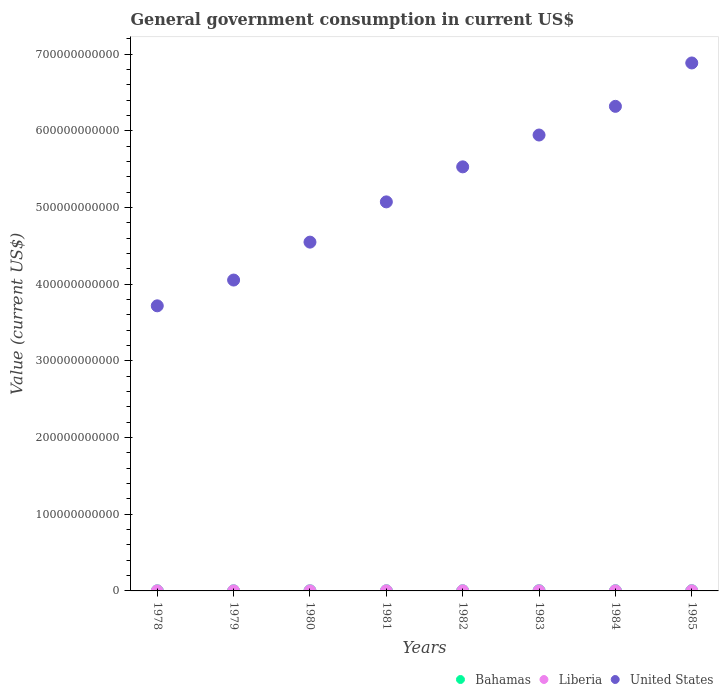What is the government conusmption in United States in 1979?
Provide a short and direct response. 4.05e+11. Across all years, what is the maximum government conusmption in United States?
Offer a terse response. 6.89e+11. Across all years, what is the minimum government conusmption in United States?
Make the answer very short. 3.72e+11. In which year was the government conusmption in Bahamas maximum?
Offer a very short reply. 1985. In which year was the government conusmption in Bahamas minimum?
Your answer should be very brief. 1978. What is the total government conusmption in Bahamas in the graph?
Your answer should be very brief. 1.64e+09. What is the difference between the government conusmption in United States in 1978 and that in 1982?
Make the answer very short. -1.81e+11. What is the difference between the government conusmption in Bahamas in 1985 and the government conusmption in United States in 1978?
Ensure brevity in your answer.  -3.72e+11. What is the average government conusmption in United States per year?
Make the answer very short. 5.26e+11. In the year 1980, what is the difference between the government conusmption in Liberia and government conusmption in United States?
Provide a short and direct response. -4.55e+11. In how many years, is the government conusmption in Bahamas greater than 680000000000 US$?
Offer a very short reply. 0. What is the ratio of the government conusmption in United States in 1979 to that in 1982?
Your answer should be very brief. 0.73. Is the government conusmption in Bahamas in 1978 less than that in 1983?
Keep it short and to the point. Yes. What is the difference between the highest and the second highest government conusmption in United States?
Your answer should be very brief. 5.66e+1. What is the difference between the highest and the lowest government conusmption in Bahamas?
Offer a very short reply. 1.61e+08. In how many years, is the government conusmption in United States greater than the average government conusmption in United States taken over all years?
Your answer should be compact. 4. Is the sum of the government conusmption in Liberia in 1981 and 1982 greater than the maximum government conusmption in United States across all years?
Your answer should be very brief. No. Is it the case that in every year, the sum of the government conusmption in Liberia and government conusmption in Bahamas  is greater than the government conusmption in United States?
Make the answer very short. No. Does the government conusmption in United States monotonically increase over the years?
Provide a short and direct response. Yes. Is the government conusmption in Bahamas strictly greater than the government conusmption in Liberia over the years?
Keep it short and to the point. No. What is the difference between two consecutive major ticks on the Y-axis?
Your answer should be compact. 1.00e+11. Are the values on the major ticks of Y-axis written in scientific E-notation?
Give a very brief answer. No. Does the graph contain grids?
Your answer should be very brief. No. How are the legend labels stacked?
Offer a terse response. Horizontal. What is the title of the graph?
Offer a very short reply. General government consumption in current US$. What is the label or title of the Y-axis?
Provide a succinct answer. Value (current US$). What is the Value (current US$) of Bahamas in 1978?
Your answer should be compact. 1.28e+08. What is the Value (current US$) in Liberia in 1978?
Your answer should be compact. 1.39e+08. What is the Value (current US$) in United States in 1978?
Your response must be concise. 3.72e+11. What is the Value (current US$) in Bahamas in 1979?
Offer a terse response. 1.44e+08. What is the Value (current US$) of Liberia in 1979?
Provide a short and direct response. 1.57e+08. What is the Value (current US$) of United States in 1979?
Ensure brevity in your answer.  4.05e+11. What is the Value (current US$) of Bahamas in 1980?
Your answer should be compact. 1.67e+08. What is the Value (current US$) of Liberia in 1980?
Give a very brief answer. 1.82e+08. What is the Value (current US$) in United States in 1980?
Offer a very short reply. 4.55e+11. What is the Value (current US$) of Bahamas in 1981?
Provide a succinct answer. 1.97e+08. What is the Value (current US$) of Liberia in 1981?
Offer a terse response. 2.11e+08. What is the Value (current US$) of United States in 1981?
Your response must be concise. 5.07e+11. What is the Value (current US$) of Bahamas in 1982?
Provide a succinct answer. 2.09e+08. What is the Value (current US$) of Liberia in 1982?
Your answer should be very brief. 2.43e+08. What is the Value (current US$) in United States in 1982?
Your answer should be very brief. 5.53e+11. What is the Value (current US$) of Bahamas in 1983?
Offer a terse response. 2.38e+08. What is the Value (current US$) in Liberia in 1983?
Ensure brevity in your answer.  2.04e+08. What is the Value (current US$) of United States in 1983?
Keep it short and to the point. 5.95e+11. What is the Value (current US$) of Bahamas in 1984?
Provide a short and direct response. 2.64e+08. What is the Value (current US$) of Liberia in 1984?
Provide a short and direct response. 1.87e+08. What is the Value (current US$) of United States in 1984?
Your answer should be very brief. 6.32e+11. What is the Value (current US$) in Bahamas in 1985?
Keep it short and to the point. 2.89e+08. What is the Value (current US$) in Liberia in 1985?
Keep it short and to the point. 2.30e+08. What is the Value (current US$) in United States in 1985?
Keep it short and to the point. 6.89e+11. Across all years, what is the maximum Value (current US$) in Bahamas?
Offer a very short reply. 2.89e+08. Across all years, what is the maximum Value (current US$) in Liberia?
Give a very brief answer. 2.43e+08. Across all years, what is the maximum Value (current US$) of United States?
Ensure brevity in your answer.  6.89e+11. Across all years, what is the minimum Value (current US$) of Bahamas?
Your answer should be very brief. 1.28e+08. Across all years, what is the minimum Value (current US$) of Liberia?
Your answer should be very brief. 1.39e+08. Across all years, what is the minimum Value (current US$) in United States?
Keep it short and to the point. 3.72e+11. What is the total Value (current US$) in Bahamas in the graph?
Offer a terse response. 1.64e+09. What is the total Value (current US$) of Liberia in the graph?
Your response must be concise. 1.55e+09. What is the total Value (current US$) of United States in the graph?
Give a very brief answer. 4.21e+12. What is the difference between the Value (current US$) in Bahamas in 1978 and that in 1979?
Offer a very short reply. -1.54e+07. What is the difference between the Value (current US$) of Liberia in 1978 and that in 1979?
Make the answer very short. -1.76e+07. What is the difference between the Value (current US$) of United States in 1978 and that in 1979?
Give a very brief answer. -3.36e+1. What is the difference between the Value (current US$) in Bahamas in 1978 and that in 1980?
Ensure brevity in your answer.  -3.86e+07. What is the difference between the Value (current US$) of Liberia in 1978 and that in 1980?
Your answer should be compact. -4.30e+07. What is the difference between the Value (current US$) of United States in 1978 and that in 1980?
Provide a succinct answer. -8.31e+1. What is the difference between the Value (current US$) in Bahamas in 1978 and that in 1981?
Provide a short and direct response. -6.89e+07. What is the difference between the Value (current US$) in Liberia in 1978 and that in 1981?
Your answer should be very brief. -7.20e+07. What is the difference between the Value (current US$) in United States in 1978 and that in 1981?
Your response must be concise. -1.36e+11. What is the difference between the Value (current US$) of Bahamas in 1978 and that in 1982?
Offer a very short reply. -8.05e+07. What is the difference between the Value (current US$) in Liberia in 1978 and that in 1982?
Keep it short and to the point. -1.04e+08. What is the difference between the Value (current US$) in United States in 1978 and that in 1982?
Provide a succinct answer. -1.81e+11. What is the difference between the Value (current US$) of Bahamas in 1978 and that in 1983?
Ensure brevity in your answer.  -1.10e+08. What is the difference between the Value (current US$) of Liberia in 1978 and that in 1983?
Provide a short and direct response. -6.50e+07. What is the difference between the Value (current US$) of United States in 1978 and that in 1983?
Keep it short and to the point. -2.23e+11. What is the difference between the Value (current US$) in Bahamas in 1978 and that in 1984?
Make the answer very short. -1.36e+08. What is the difference between the Value (current US$) in Liberia in 1978 and that in 1984?
Your answer should be very brief. -4.80e+07. What is the difference between the Value (current US$) of United States in 1978 and that in 1984?
Provide a short and direct response. -2.60e+11. What is the difference between the Value (current US$) in Bahamas in 1978 and that in 1985?
Your answer should be very brief. -1.61e+08. What is the difference between the Value (current US$) in Liberia in 1978 and that in 1985?
Offer a very short reply. -9.10e+07. What is the difference between the Value (current US$) in United States in 1978 and that in 1985?
Your answer should be very brief. -3.17e+11. What is the difference between the Value (current US$) of Bahamas in 1979 and that in 1980?
Offer a very short reply. -2.32e+07. What is the difference between the Value (current US$) in Liberia in 1979 and that in 1980?
Provide a succinct answer. -2.54e+07. What is the difference between the Value (current US$) of United States in 1979 and that in 1980?
Ensure brevity in your answer.  -4.95e+1. What is the difference between the Value (current US$) in Bahamas in 1979 and that in 1981?
Keep it short and to the point. -5.35e+07. What is the difference between the Value (current US$) of Liberia in 1979 and that in 1981?
Provide a succinct answer. -5.44e+07. What is the difference between the Value (current US$) in United States in 1979 and that in 1981?
Keep it short and to the point. -1.02e+11. What is the difference between the Value (current US$) of Bahamas in 1979 and that in 1982?
Offer a terse response. -6.51e+07. What is the difference between the Value (current US$) of Liberia in 1979 and that in 1982?
Make the answer very short. -8.64e+07. What is the difference between the Value (current US$) of United States in 1979 and that in 1982?
Your answer should be compact. -1.48e+11. What is the difference between the Value (current US$) of Bahamas in 1979 and that in 1983?
Your response must be concise. -9.42e+07. What is the difference between the Value (current US$) in Liberia in 1979 and that in 1983?
Ensure brevity in your answer.  -4.74e+07. What is the difference between the Value (current US$) of United States in 1979 and that in 1983?
Your answer should be very brief. -1.89e+11. What is the difference between the Value (current US$) in Bahamas in 1979 and that in 1984?
Your response must be concise. -1.20e+08. What is the difference between the Value (current US$) of Liberia in 1979 and that in 1984?
Your answer should be very brief. -3.04e+07. What is the difference between the Value (current US$) in United States in 1979 and that in 1984?
Offer a terse response. -2.27e+11. What is the difference between the Value (current US$) of Bahamas in 1979 and that in 1985?
Offer a terse response. -1.45e+08. What is the difference between the Value (current US$) of Liberia in 1979 and that in 1985?
Your response must be concise. -7.34e+07. What is the difference between the Value (current US$) in United States in 1979 and that in 1985?
Provide a short and direct response. -2.83e+11. What is the difference between the Value (current US$) in Bahamas in 1980 and that in 1981?
Your answer should be compact. -3.03e+07. What is the difference between the Value (current US$) of Liberia in 1980 and that in 1981?
Your answer should be very brief. -2.90e+07. What is the difference between the Value (current US$) of United States in 1980 and that in 1981?
Your answer should be very brief. -5.25e+1. What is the difference between the Value (current US$) of Bahamas in 1980 and that in 1982?
Your answer should be very brief. -4.19e+07. What is the difference between the Value (current US$) of Liberia in 1980 and that in 1982?
Keep it short and to the point. -6.10e+07. What is the difference between the Value (current US$) of United States in 1980 and that in 1982?
Provide a short and direct response. -9.82e+1. What is the difference between the Value (current US$) in Bahamas in 1980 and that in 1983?
Provide a succinct answer. -7.10e+07. What is the difference between the Value (current US$) of Liberia in 1980 and that in 1983?
Offer a very short reply. -2.20e+07. What is the difference between the Value (current US$) of United States in 1980 and that in 1983?
Make the answer very short. -1.40e+11. What is the difference between the Value (current US$) in Bahamas in 1980 and that in 1984?
Your response must be concise. -9.70e+07. What is the difference between the Value (current US$) in Liberia in 1980 and that in 1984?
Your answer should be compact. -5.00e+06. What is the difference between the Value (current US$) of United States in 1980 and that in 1984?
Make the answer very short. -1.77e+11. What is the difference between the Value (current US$) of Bahamas in 1980 and that in 1985?
Keep it short and to the point. -1.22e+08. What is the difference between the Value (current US$) of Liberia in 1980 and that in 1985?
Provide a short and direct response. -4.80e+07. What is the difference between the Value (current US$) of United States in 1980 and that in 1985?
Keep it short and to the point. -2.34e+11. What is the difference between the Value (current US$) of Bahamas in 1981 and that in 1982?
Your answer should be very brief. -1.16e+07. What is the difference between the Value (current US$) of Liberia in 1981 and that in 1982?
Provide a short and direct response. -3.20e+07. What is the difference between the Value (current US$) of United States in 1981 and that in 1982?
Ensure brevity in your answer.  -4.57e+1. What is the difference between the Value (current US$) of Bahamas in 1981 and that in 1983?
Ensure brevity in your answer.  -4.07e+07. What is the difference between the Value (current US$) in Liberia in 1981 and that in 1983?
Your answer should be compact. 7.00e+06. What is the difference between the Value (current US$) of United States in 1981 and that in 1983?
Provide a short and direct response. -8.72e+1. What is the difference between the Value (current US$) in Bahamas in 1981 and that in 1984?
Provide a short and direct response. -6.67e+07. What is the difference between the Value (current US$) in Liberia in 1981 and that in 1984?
Your answer should be compact. 2.40e+07. What is the difference between the Value (current US$) in United States in 1981 and that in 1984?
Give a very brief answer. -1.25e+11. What is the difference between the Value (current US$) of Bahamas in 1981 and that in 1985?
Provide a short and direct response. -9.18e+07. What is the difference between the Value (current US$) of Liberia in 1981 and that in 1985?
Your answer should be compact. -1.90e+07. What is the difference between the Value (current US$) in United States in 1981 and that in 1985?
Ensure brevity in your answer.  -1.81e+11. What is the difference between the Value (current US$) in Bahamas in 1982 and that in 1983?
Keep it short and to the point. -2.91e+07. What is the difference between the Value (current US$) of Liberia in 1982 and that in 1983?
Give a very brief answer. 3.90e+07. What is the difference between the Value (current US$) of United States in 1982 and that in 1983?
Your answer should be very brief. -4.15e+1. What is the difference between the Value (current US$) of Bahamas in 1982 and that in 1984?
Your response must be concise. -5.51e+07. What is the difference between the Value (current US$) in Liberia in 1982 and that in 1984?
Give a very brief answer. 5.60e+07. What is the difference between the Value (current US$) of United States in 1982 and that in 1984?
Provide a succinct answer. -7.89e+1. What is the difference between the Value (current US$) of Bahamas in 1982 and that in 1985?
Your response must be concise. -8.02e+07. What is the difference between the Value (current US$) in Liberia in 1982 and that in 1985?
Your response must be concise. 1.30e+07. What is the difference between the Value (current US$) in United States in 1982 and that in 1985?
Offer a terse response. -1.35e+11. What is the difference between the Value (current US$) in Bahamas in 1983 and that in 1984?
Offer a terse response. -2.60e+07. What is the difference between the Value (current US$) in Liberia in 1983 and that in 1984?
Your answer should be compact. 1.70e+07. What is the difference between the Value (current US$) in United States in 1983 and that in 1984?
Give a very brief answer. -3.74e+1. What is the difference between the Value (current US$) of Bahamas in 1983 and that in 1985?
Your answer should be very brief. -5.11e+07. What is the difference between the Value (current US$) of Liberia in 1983 and that in 1985?
Keep it short and to the point. -2.60e+07. What is the difference between the Value (current US$) in United States in 1983 and that in 1985?
Ensure brevity in your answer.  -9.40e+1. What is the difference between the Value (current US$) of Bahamas in 1984 and that in 1985?
Your response must be concise. -2.51e+07. What is the difference between the Value (current US$) in Liberia in 1984 and that in 1985?
Your answer should be compact. -4.30e+07. What is the difference between the Value (current US$) of United States in 1984 and that in 1985?
Your response must be concise. -5.66e+1. What is the difference between the Value (current US$) in Bahamas in 1978 and the Value (current US$) in Liberia in 1979?
Provide a succinct answer. -2.82e+07. What is the difference between the Value (current US$) in Bahamas in 1978 and the Value (current US$) in United States in 1979?
Your response must be concise. -4.05e+11. What is the difference between the Value (current US$) in Liberia in 1978 and the Value (current US$) in United States in 1979?
Provide a succinct answer. -4.05e+11. What is the difference between the Value (current US$) of Bahamas in 1978 and the Value (current US$) of Liberia in 1980?
Provide a short and direct response. -5.36e+07. What is the difference between the Value (current US$) in Bahamas in 1978 and the Value (current US$) in United States in 1980?
Your answer should be very brief. -4.55e+11. What is the difference between the Value (current US$) in Liberia in 1978 and the Value (current US$) in United States in 1980?
Your answer should be very brief. -4.55e+11. What is the difference between the Value (current US$) of Bahamas in 1978 and the Value (current US$) of Liberia in 1981?
Provide a short and direct response. -8.26e+07. What is the difference between the Value (current US$) of Bahamas in 1978 and the Value (current US$) of United States in 1981?
Provide a succinct answer. -5.07e+11. What is the difference between the Value (current US$) in Liberia in 1978 and the Value (current US$) in United States in 1981?
Your response must be concise. -5.07e+11. What is the difference between the Value (current US$) in Bahamas in 1978 and the Value (current US$) in Liberia in 1982?
Your answer should be very brief. -1.15e+08. What is the difference between the Value (current US$) in Bahamas in 1978 and the Value (current US$) in United States in 1982?
Make the answer very short. -5.53e+11. What is the difference between the Value (current US$) of Liberia in 1978 and the Value (current US$) of United States in 1982?
Offer a terse response. -5.53e+11. What is the difference between the Value (current US$) in Bahamas in 1978 and the Value (current US$) in Liberia in 1983?
Your answer should be compact. -7.56e+07. What is the difference between the Value (current US$) of Bahamas in 1978 and the Value (current US$) of United States in 1983?
Your answer should be very brief. -5.94e+11. What is the difference between the Value (current US$) of Liberia in 1978 and the Value (current US$) of United States in 1983?
Your answer should be very brief. -5.94e+11. What is the difference between the Value (current US$) in Bahamas in 1978 and the Value (current US$) in Liberia in 1984?
Keep it short and to the point. -5.86e+07. What is the difference between the Value (current US$) in Bahamas in 1978 and the Value (current US$) in United States in 1984?
Offer a very short reply. -6.32e+11. What is the difference between the Value (current US$) in Liberia in 1978 and the Value (current US$) in United States in 1984?
Provide a succinct answer. -6.32e+11. What is the difference between the Value (current US$) in Bahamas in 1978 and the Value (current US$) in Liberia in 1985?
Give a very brief answer. -1.02e+08. What is the difference between the Value (current US$) of Bahamas in 1978 and the Value (current US$) of United States in 1985?
Keep it short and to the point. -6.88e+11. What is the difference between the Value (current US$) in Liberia in 1978 and the Value (current US$) in United States in 1985?
Offer a very short reply. -6.88e+11. What is the difference between the Value (current US$) of Bahamas in 1979 and the Value (current US$) of Liberia in 1980?
Offer a very short reply. -3.82e+07. What is the difference between the Value (current US$) in Bahamas in 1979 and the Value (current US$) in United States in 1980?
Your response must be concise. -4.55e+11. What is the difference between the Value (current US$) of Liberia in 1979 and the Value (current US$) of United States in 1980?
Your answer should be very brief. -4.55e+11. What is the difference between the Value (current US$) of Bahamas in 1979 and the Value (current US$) of Liberia in 1981?
Ensure brevity in your answer.  -6.72e+07. What is the difference between the Value (current US$) of Bahamas in 1979 and the Value (current US$) of United States in 1981?
Offer a terse response. -5.07e+11. What is the difference between the Value (current US$) in Liberia in 1979 and the Value (current US$) in United States in 1981?
Ensure brevity in your answer.  -5.07e+11. What is the difference between the Value (current US$) in Bahamas in 1979 and the Value (current US$) in Liberia in 1982?
Make the answer very short. -9.92e+07. What is the difference between the Value (current US$) in Bahamas in 1979 and the Value (current US$) in United States in 1982?
Ensure brevity in your answer.  -5.53e+11. What is the difference between the Value (current US$) in Liberia in 1979 and the Value (current US$) in United States in 1982?
Provide a succinct answer. -5.53e+11. What is the difference between the Value (current US$) in Bahamas in 1979 and the Value (current US$) in Liberia in 1983?
Make the answer very short. -6.02e+07. What is the difference between the Value (current US$) in Bahamas in 1979 and the Value (current US$) in United States in 1983?
Keep it short and to the point. -5.94e+11. What is the difference between the Value (current US$) of Liberia in 1979 and the Value (current US$) of United States in 1983?
Offer a very short reply. -5.94e+11. What is the difference between the Value (current US$) of Bahamas in 1979 and the Value (current US$) of Liberia in 1984?
Provide a succinct answer. -4.32e+07. What is the difference between the Value (current US$) in Bahamas in 1979 and the Value (current US$) in United States in 1984?
Make the answer very short. -6.32e+11. What is the difference between the Value (current US$) of Liberia in 1979 and the Value (current US$) of United States in 1984?
Give a very brief answer. -6.32e+11. What is the difference between the Value (current US$) of Bahamas in 1979 and the Value (current US$) of Liberia in 1985?
Keep it short and to the point. -8.62e+07. What is the difference between the Value (current US$) in Bahamas in 1979 and the Value (current US$) in United States in 1985?
Your response must be concise. -6.88e+11. What is the difference between the Value (current US$) in Liberia in 1979 and the Value (current US$) in United States in 1985?
Your response must be concise. -6.88e+11. What is the difference between the Value (current US$) of Bahamas in 1980 and the Value (current US$) of Liberia in 1981?
Your answer should be very brief. -4.40e+07. What is the difference between the Value (current US$) in Bahamas in 1980 and the Value (current US$) in United States in 1981?
Your answer should be compact. -5.07e+11. What is the difference between the Value (current US$) in Liberia in 1980 and the Value (current US$) in United States in 1981?
Offer a very short reply. -5.07e+11. What is the difference between the Value (current US$) of Bahamas in 1980 and the Value (current US$) of Liberia in 1982?
Provide a short and direct response. -7.60e+07. What is the difference between the Value (current US$) in Bahamas in 1980 and the Value (current US$) in United States in 1982?
Keep it short and to the point. -5.53e+11. What is the difference between the Value (current US$) of Liberia in 1980 and the Value (current US$) of United States in 1982?
Provide a short and direct response. -5.53e+11. What is the difference between the Value (current US$) in Bahamas in 1980 and the Value (current US$) in Liberia in 1983?
Provide a succinct answer. -3.70e+07. What is the difference between the Value (current US$) of Bahamas in 1980 and the Value (current US$) of United States in 1983?
Provide a succinct answer. -5.94e+11. What is the difference between the Value (current US$) of Liberia in 1980 and the Value (current US$) of United States in 1983?
Provide a short and direct response. -5.94e+11. What is the difference between the Value (current US$) in Bahamas in 1980 and the Value (current US$) in Liberia in 1984?
Offer a terse response. -2.00e+07. What is the difference between the Value (current US$) in Bahamas in 1980 and the Value (current US$) in United States in 1984?
Offer a terse response. -6.32e+11. What is the difference between the Value (current US$) in Liberia in 1980 and the Value (current US$) in United States in 1984?
Your response must be concise. -6.32e+11. What is the difference between the Value (current US$) in Bahamas in 1980 and the Value (current US$) in Liberia in 1985?
Ensure brevity in your answer.  -6.30e+07. What is the difference between the Value (current US$) in Bahamas in 1980 and the Value (current US$) in United States in 1985?
Your response must be concise. -6.88e+11. What is the difference between the Value (current US$) of Liberia in 1980 and the Value (current US$) of United States in 1985?
Make the answer very short. -6.88e+11. What is the difference between the Value (current US$) of Bahamas in 1981 and the Value (current US$) of Liberia in 1982?
Your answer should be very brief. -4.57e+07. What is the difference between the Value (current US$) in Bahamas in 1981 and the Value (current US$) in United States in 1982?
Provide a short and direct response. -5.53e+11. What is the difference between the Value (current US$) in Liberia in 1981 and the Value (current US$) in United States in 1982?
Give a very brief answer. -5.53e+11. What is the difference between the Value (current US$) of Bahamas in 1981 and the Value (current US$) of Liberia in 1983?
Keep it short and to the point. -6.70e+06. What is the difference between the Value (current US$) in Bahamas in 1981 and the Value (current US$) in United States in 1983?
Offer a terse response. -5.94e+11. What is the difference between the Value (current US$) of Liberia in 1981 and the Value (current US$) of United States in 1983?
Provide a short and direct response. -5.94e+11. What is the difference between the Value (current US$) in Bahamas in 1981 and the Value (current US$) in Liberia in 1984?
Your answer should be compact. 1.03e+07. What is the difference between the Value (current US$) in Bahamas in 1981 and the Value (current US$) in United States in 1984?
Your answer should be compact. -6.32e+11. What is the difference between the Value (current US$) in Liberia in 1981 and the Value (current US$) in United States in 1984?
Your answer should be compact. -6.32e+11. What is the difference between the Value (current US$) in Bahamas in 1981 and the Value (current US$) in Liberia in 1985?
Your answer should be compact. -3.27e+07. What is the difference between the Value (current US$) of Bahamas in 1981 and the Value (current US$) of United States in 1985?
Make the answer very short. -6.88e+11. What is the difference between the Value (current US$) in Liberia in 1981 and the Value (current US$) in United States in 1985?
Give a very brief answer. -6.88e+11. What is the difference between the Value (current US$) of Bahamas in 1982 and the Value (current US$) of Liberia in 1983?
Ensure brevity in your answer.  4.90e+06. What is the difference between the Value (current US$) in Bahamas in 1982 and the Value (current US$) in United States in 1983?
Ensure brevity in your answer.  -5.94e+11. What is the difference between the Value (current US$) of Liberia in 1982 and the Value (current US$) of United States in 1983?
Your answer should be very brief. -5.94e+11. What is the difference between the Value (current US$) in Bahamas in 1982 and the Value (current US$) in Liberia in 1984?
Ensure brevity in your answer.  2.19e+07. What is the difference between the Value (current US$) of Bahamas in 1982 and the Value (current US$) of United States in 1984?
Your response must be concise. -6.32e+11. What is the difference between the Value (current US$) of Liberia in 1982 and the Value (current US$) of United States in 1984?
Provide a short and direct response. -6.32e+11. What is the difference between the Value (current US$) in Bahamas in 1982 and the Value (current US$) in Liberia in 1985?
Ensure brevity in your answer.  -2.11e+07. What is the difference between the Value (current US$) in Bahamas in 1982 and the Value (current US$) in United States in 1985?
Offer a very short reply. -6.88e+11. What is the difference between the Value (current US$) of Liberia in 1982 and the Value (current US$) of United States in 1985?
Provide a succinct answer. -6.88e+11. What is the difference between the Value (current US$) in Bahamas in 1983 and the Value (current US$) in Liberia in 1984?
Provide a succinct answer. 5.10e+07. What is the difference between the Value (current US$) of Bahamas in 1983 and the Value (current US$) of United States in 1984?
Give a very brief answer. -6.32e+11. What is the difference between the Value (current US$) in Liberia in 1983 and the Value (current US$) in United States in 1984?
Provide a short and direct response. -6.32e+11. What is the difference between the Value (current US$) of Bahamas in 1983 and the Value (current US$) of United States in 1985?
Provide a short and direct response. -6.88e+11. What is the difference between the Value (current US$) in Liberia in 1983 and the Value (current US$) in United States in 1985?
Provide a short and direct response. -6.88e+11. What is the difference between the Value (current US$) of Bahamas in 1984 and the Value (current US$) of Liberia in 1985?
Provide a short and direct response. 3.40e+07. What is the difference between the Value (current US$) in Bahamas in 1984 and the Value (current US$) in United States in 1985?
Give a very brief answer. -6.88e+11. What is the difference between the Value (current US$) of Liberia in 1984 and the Value (current US$) of United States in 1985?
Provide a succinct answer. -6.88e+11. What is the average Value (current US$) in Bahamas per year?
Give a very brief answer. 2.05e+08. What is the average Value (current US$) of Liberia per year?
Offer a very short reply. 1.94e+08. What is the average Value (current US$) of United States per year?
Make the answer very short. 5.26e+11. In the year 1978, what is the difference between the Value (current US$) of Bahamas and Value (current US$) of Liberia?
Give a very brief answer. -1.06e+07. In the year 1978, what is the difference between the Value (current US$) in Bahamas and Value (current US$) in United States?
Offer a very short reply. -3.72e+11. In the year 1978, what is the difference between the Value (current US$) of Liberia and Value (current US$) of United States?
Ensure brevity in your answer.  -3.72e+11. In the year 1979, what is the difference between the Value (current US$) in Bahamas and Value (current US$) in Liberia?
Your answer should be very brief. -1.28e+07. In the year 1979, what is the difference between the Value (current US$) of Bahamas and Value (current US$) of United States?
Provide a short and direct response. -4.05e+11. In the year 1979, what is the difference between the Value (current US$) in Liberia and Value (current US$) in United States?
Provide a succinct answer. -4.05e+11. In the year 1980, what is the difference between the Value (current US$) of Bahamas and Value (current US$) of Liberia?
Give a very brief answer. -1.50e+07. In the year 1980, what is the difference between the Value (current US$) of Bahamas and Value (current US$) of United States?
Your answer should be very brief. -4.55e+11. In the year 1980, what is the difference between the Value (current US$) of Liberia and Value (current US$) of United States?
Offer a terse response. -4.55e+11. In the year 1981, what is the difference between the Value (current US$) of Bahamas and Value (current US$) of Liberia?
Ensure brevity in your answer.  -1.37e+07. In the year 1981, what is the difference between the Value (current US$) of Bahamas and Value (current US$) of United States?
Offer a very short reply. -5.07e+11. In the year 1981, what is the difference between the Value (current US$) in Liberia and Value (current US$) in United States?
Give a very brief answer. -5.07e+11. In the year 1982, what is the difference between the Value (current US$) in Bahamas and Value (current US$) in Liberia?
Provide a short and direct response. -3.41e+07. In the year 1982, what is the difference between the Value (current US$) of Bahamas and Value (current US$) of United States?
Provide a short and direct response. -5.53e+11. In the year 1982, what is the difference between the Value (current US$) of Liberia and Value (current US$) of United States?
Keep it short and to the point. -5.53e+11. In the year 1983, what is the difference between the Value (current US$) of Bahamas and Value (current US$) of Liberia?
Make the answer very short. 3.40e+07. In the year 1983, what is the difference between the Value (current US$) of Bahamas and Value (current US$) of United States?
Keep it short and to the point. -5.94e+11. In the year 1983, what is the difference between the Value (current US$) in Liberia and Value (current US$) in United States?
Your answer should be compact. -5.94e+11. In the year 1984, what is the difference between the Value (current US$) in Bahamas and Value (current US$) in Liberia?
Offer a very short reply. 7.70e+07. In the year 1984, what is the difference between the Value (current US$) in Bahamas and Value (current US$) in United States?
Offer a very short reply. -6.32e+11. In the year 1984, what is the difference between the Value (current US$) of Liberia and Value (current US$) of United States?
Your answer should be compact. -6.32e+11. In the year 1985, what is the difference between the Value (current US$) of Bahamas and Value (current US$) of Liberia?
Offer a terse response. 5.91e+07. In the year 1985, what is the difference between the Value (current US$) in Bahamas and Value (current US$) in United States?
Give a very brief answer. -6.88e+11. In the year 1985, what is the difference between the Value (current US$) in Liberia and Value (current US$) in United States?
Give a very brief answer. -6.88e+11. What is the ratio of the Value (current US$) in Bahamas in 1978 to that in 1979?
Make the answer very short. 0.89. What is the ratio of the Value (current US$) in Liberia in 1978 to that in 1979?
Keep it short and to the point. 0.89. What is the ratio of the Value (current US$) of United States in 1978 to that in 1979?
Your answer should be very brief. 0.92. What is the ratio of the Value (current US$) of Bahamas in 1978 to that in 1980?
Your answer should be very brief. 0.77. What is the ratio of the Value (current US$) of Liberia in 1978 to that in 1980?
Your response must be concise. 0.76. What is the ratio of the Value (current US$) of United States in 1978 to that in 1980?
Your response must be concise. 0.82. What is the ratio of the Value (current US$) of Bahamas in 1978 to that in 1981?
Your response must be concise. 0.65. What is the ratio of the Value (current US$) in Liberia in 1978 to that in 1981?
Provide a succinct answer. 0.66. What is the ratio of the Value (current US$) in United States in 1978 to that in 1981?
Your response must be concise. 0.73. What is the ratio of the Value (current US$) of Bahamas in 1978 to that in 1982?
Keep it short and to the point. 0.61. What is the ratio of the Value (current US$) of Liberia in 1978 to that in 1982?
Your response must be concise. 0.57. What is the ratio of the Value (current US$) in United States in 1978 to that in 1982?
Your response must be concise. 0.67. What is the ratio of the Value (current US$) of Bahamas in 1978 to that in 1983?
Offer a very short reply. 0.54. What is the ratio of the Value (current US$) in Liberia in 1978 to that in 1983?
Ensure brevity in your answer.  0.68. What is the ratio of the Value (current US$) of United States in 1978 to that in 1983?
Ensure brevity in your answer.  0.63. What is the ratio of the Value (current US$) of Bahamas in 1978 to that in 1984?
Your answer should be very brief. 0.49. What is the ratio of the Value (current US$) of Liberia in 1978 to that in 1984?
Offer a terse response. 0.74. What is the ratio of the Value (current US$) in United States in 1978 to that in 1984?
Your answer should be very brief. 0.59. What is the ratio of the Value (current US$) of Bahamas in 1978 to that in 1985?
Provide a short and direct response. 0.44. What is the ratio of the Value (current US$) of Liberia in 1978 to that in 1985?
Your response must be concise. 0.6. What is the ratio of the Value (current US$) in United States in 1978 to that in 1985?
Make the answer very short. 0.54. What is the ratio of the Value (current US$) in Bahamas in 1979 to that in 1980?
Give a very brief answer. 0.86. What is the ratio of the Value (current US$) in Liberia in 1979 to that in 1980?
Keep it short and to the point. 0.86. What is the ratio of the Value (current US$) of United States in 1979 to that in 1980?
Ensure brevity in your answer.  0.89. What is the ratio of the Value (current US$) in Bahamas in 1979 to that in 1981?
Your answer should be very brief. 0.73. What is the ratio of the Value (current US$) of Liberia in 1979 to that in 1981?
Provide a succinct answer. 0.74. What is the ratio of the Value (current US$) of United States in 1979 to that in 1981?
Ensure brevity in your answer.  0.8. What is the ratio of the Value (current US$) in Bahamas in 1979 to that in 1982?
Your answer should be very brief. 0.69. What is the ratio of the Value (current US$) in Liberia in 1979 to that in 1982?
Your answer should be compact. 0.64. What is the ratio of the Value (current US$) in United States in 1979 to that in 1982?
Make the answer very short. 0.73. What is the ratio of the Value (current US$) in Bahamas in 1979 to that in 1983?
Your answer should be very brief. 0.6. What is the ratio of the Value (current US$) of Liberia in 1979 to that in 1983?
Offer a very short reply. 0.77. What is the ratio of the Value (current US$) in United States in 1979 to that in 1983?
Make the answer very short. 0.68. What is the ratio of the Value (current US$) of Bahamas in 1979 to that in 1984?
Your answer should be compact. 0.54. What is the ratio of the Value (current US$) in Liberia in 1979 to that in 1984?
Ensure brevity in your answer.  0.84. What is the ratio of the Value (current US$) in United States in 1979 to that in 1984?
Your response must be concise. 0.64. What is the ratio of the Value (current US$) of Bahamas in 1979 to that in 1985?
Give a very brief answer. 0.5. What is the ratio of the Value (current US$) in Liberia in 1979 to that in 1985?
Make the answer very short. 0.68. What is the ratio of the Value (current US$) in United States in 1979 to that in 1985?
Keep it short and to the point. 0.59. What is the ratio of the Value (current US$) in Bahamas in 1980 to that in 1981?
Offer a terse response. 0.85. What is the ratio of the Value (current US$) in Liberia in 1980 to that in 1981?
Provide a succinct answer. 0.86. What is the ratio of the Value (current US$) of United States in 1980 to that in 1981?
Provide a short and direct response. 0.9. What is the ratio of the Value (current US$) in Bahamas in 1980 to that in 1982?
Offer a very short reply. 0.8. What is the ratio of the Value (current US$) of Liberia in 1980 to that in 1982?
Your response must be concise. 0.75. What is the ratio of the Value (current US$) in United States in 1980 to that in 1982?
Keep it short and to the point. 0.82. What is the ratio of the Value (current US$) in Bahamas in 1980 to that in 1983?
Offer a very short reply. 0.7. What is the ratio of the Value (current US$) of Liberia in 1980 to that in 1983?
Your answer should be very brief. 0.89. What is the ratio of the Value (current US$) of United States in 1980 to that in 1983?
Ensure brevity in your answer.  0.77. What is the ratio of the Value (current US$) in Bahamas in 1980 to that in 1984?
Give a very brief answer. 0.63. What is the ratio of the Value (current US$) of Liberia in 1980 to that in 1984?
Your answer should be compact. 0.97. What is the ratio of the Value (current US$) of United States in 1980 to that in 1984?
Your answer should be very brief. 0.72. What is the ratio of the Value (current US$) in Bahamas in 1980 to that in 1985?
Offer a very short reply. 0.58. What is the ratio of the Value (current US$) in Liberia in 1980 to that in 1985?
Your answer should be compact. 0.79. What is the ratio of the Value (current US$) of United States in 1980 to that in 1985?
Offer a very short reply. 0.66. What is the ratio of the Value (current US$) of Bahamas in 1981 to that in 1982?
Offer a very short reply. 0.94. What is the ratio of the Value (current US$) of Liberia in 1981 to that in 1982?
Your answer should be compact. 0.87. What is the ratio of the Value (current US$) of United States in 1981 to that in 1982?
Provide a succinct answer. 0.92. What is the ratio of the Value (current US$) of Bahamas in 1981 to that in 1983?
Give a very brief answer. 0.83. What is the ratio of the Value (current US$) in Liberia in 1981 to that in 1983?
Provide a succinct answer. 1.03. What is the ratio of the Value (current US$) in United States in 1981 to that in 1983?
Make the answer very short. 0.85. What is the ratio of the Value (current US$) of Bahamas in 1981 to that in 1984?
Your response must be concise. 0.75. What is the ratio of the Value (current US$) in Liberia in 1981 to that in 1984?
Ensure brevity in your answer.  1.13. What is the ratio of the Value (current US$) in United States in 1981 to that in 1984?
Ensure brevity in your answer.  0.8. What is the ratio of the Value (current US$) in Bahamas in 1981 to that in 1985?
Your answer should be compact. 0.68. What is the ratio of the Value (current US$) of Liberia in 1981 to that in 1985?
Your response must be concise. 0.92. What is the ratio of the Value (current US$) of United States in 1981 to that in 1985?
Offer a very short reply. 0.74. What is the ratio of the Value (current US$) in Bahamas in 1982 to that in 1983?
Your answer should be very brief. 0.88. What is the ratio of the Value (current US$) of Liberia in 1982 to that in 1983?
Make the answer very short. 1.19. What is the ratio of the Value (current US$) of United States in 1982 to that in 1983?
Offer a very short reply. 0.93. What is the ratio of the Value (current US$) of Bahamas in 1982 to that in 1984?
Your answer should be very brief. 0.79. What is the ratio of the Value (current US$) in Liberia in 1982 to that in 1984?
Your answer should be compact. 1.3. What is the ratio of the Value (current US$) in United States in 1982 to that in 1984?
Offer a very short reply. 0.88. What is the ratio of the Value (current US$) in Bahamas in 1982 to that in 1985?
Offer a very short reply. 0.72. What is the ratio of the Value (current US$) of Liberia in 1982 to that in 1985?
Your answer should be compact. 1.06. What is the ratio of the Value (current US$) of United States in 1982 to that in 1985?
Your answer should be compact. 0.8. What is the ratio of the Value (current US$) in Bahamas in 1983 to that in 1984?
Keep it short and to the point. 0.9. What is the ratio of the Value (current US$) of Liberia in 1983 to that in 1984?
Offer a very short reply. 1.09. What is the ratio of the Value (current US$) in United States in 1983 to that in 1984?
Provide a succinct answer. 0.94. What is the ratio of the Value (current US$) of Bahamas in 1983 to that in 1985?
Your answer should be very brief. 0.82. What is the ratio of the Value (current US$) of Liberia in 1983 to that in 1985?
Make the answer very short. 0.89. What is the ratio of the Value (current US$) in United States in 1983 to that in 1985?
Ensure brevity in your answer.  0.86. What is the ratio of the Value (current US$) in Bahamas in 1984 to that in 1985?
Ensure brevity in your answer.  0.91. What is the ratio of the Value (current US$) in Liberia in 1984 to that in 1985?
Give a very brief answer. 0.81. What is the ratio of the Value (current US$) of United States in 1984 to that in 1985?
Your answer should be compact. 0.92. What is the difference between the highest and the second highest Value (current US$) in Bahamas?
Keep it short and to the point. 2.51e+07. What is the difference between the highest and the second highest Value (current US$) in Liberia?
Offer a terse response. 1.30e+07. What is the difference between the highest and the second highest Value (current US$) of United States?
Your answer should be compact. 5.66e+1. What is the difference between the highest and the lowest Value (current US$) in Bahamas?
Offer a very short reply. 1.61e+08. What is the difference between the highest and the lowest Value (current US$) in Liberia?
Make the answer very short. 1.04e+08. What is the difference between the highest and the lowest Value (current US$) in United States?
Offer a terse response. 3.17e+11. 